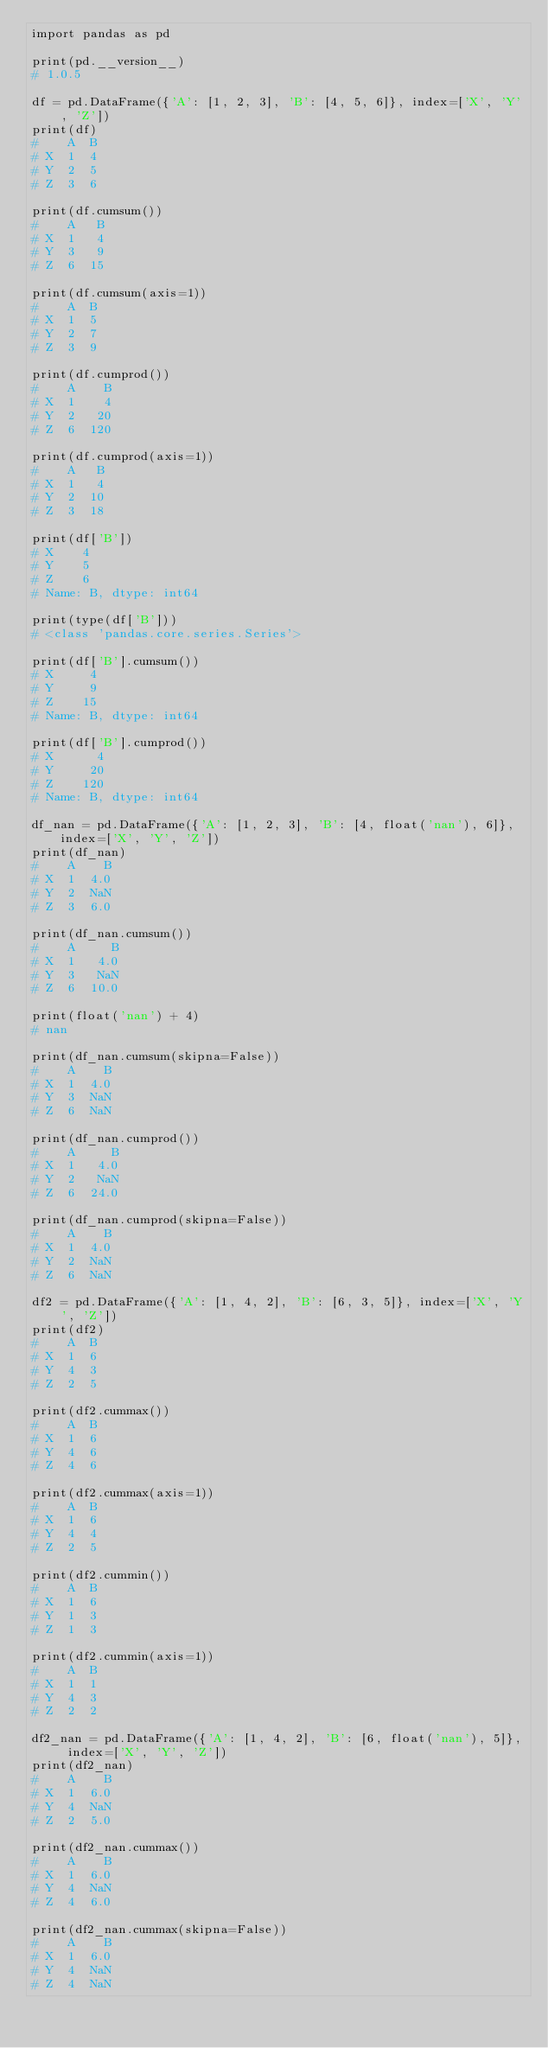<code> <loc_0><loc_0><loc_500><loc_500><_Python_>import pandas as pd

print(pd.__version__)
# 1.0.5

df = pd.DataFrame({'A': [1, 2, 3], 'B': [4, 5, 6]}, index=['X', 'Y', 'Z'])
print(df)
#    A  B
# X  1  4
# Y  2  5
# Z  3  6

print(df.cumsum())
#    A   B
# X  1   4
# Y  3   9
# Z  6  15

print(df.cumsum(axis=1))
#    A  B
# X  1  5
# Y  2  7
# Z  3  9

print(df.cumprod())
#    A    B
# X  1    4
# Y  2   20
# Z  6  120

print(df.cumprod(axis=1))
#    A   B
# X  1   4
# Y  2  10
# Z  3  18

print(df['B'])
# X    4
# Y    5
# Z    6
# Name: B, dtype: int64

print(type(df['B']))
# <class 'pandas.core.series.Series'>

print(df['B'].cumsum())
# X     4
# Y     9
# Z    15
# Name: B, dtype: int64

print(df['B'].cumprod())
# X      4
# Y     20
# Z    120
# Name: B, dtype: int64

df_nan = pd.DataFrame({'A': [1, 2, 3], 'B': [4, float('nan'), 6]}, index=['X', 'Y', 'Z'])
print(df_nan)
#    A    B
# X  1  4.0
# Y  2  NaN
# Z  3  6.0

print(df_nan.cumsum())
#    A     B
# X  1   4.0
# Y  3   NaN
# Z  6  10.0

print(float('nan') + 4)
# nan

print(df_nan.cumsum(skipna=False))
#    A    B
# X  1  4.0
# Y  3  NaN
# Z  6  NaN

print(df_nan.cumprod())
#    A     B
# X  1   4.0
# Y  2   NaN
# Z  6  24.0

print(df_nan.cumprod(skipna=False))
#    A    B
# X  1  4.0
# Y  2  NaN
# Z  6  NaN

df2 = pd.DataFrame({'A': [1, 4, 2], 'B': [6, 3, 5]}, index=['X', 'Y', 'Z'])
print(df2)
#    A  B
# X  1  6
# Y  4  3
# Z  2  5

print(df2.cummax())
#    A  B
# X  1  6
# Y  4  6
# Z  4  6

print(df2.cummax(axis=1))
#    A  B
# X  1  6
# Y  4  4
# Z  2  5

print(df2.cummin())
#    A  B
# X  1  6
# Y  1  3
# Z  1  3

print(df2.cummin(axis=1))
#    A  B
# X  1  1
# Y  4  3
# Z  2  2

df2_nan = pd.DataFrame({'A': [1, 4, 2], 'B': [6, float('nan'), 5]}, index=['X', 'Y', 'Z'])
print(df2_nan)
#    A    B
# X  1  6.0
# Y  4  NaN
# Z  2  5.0

print(df2_nan.cummax())
#    A    B
# X  1  6.0
# Y  4  NaN
# Z  4  6.0

print(df2_nan.cummax(skipna=False))
#    A    B
# X  1  6.0
# Y  4  NaN
# Z  4  NaN
</code> 